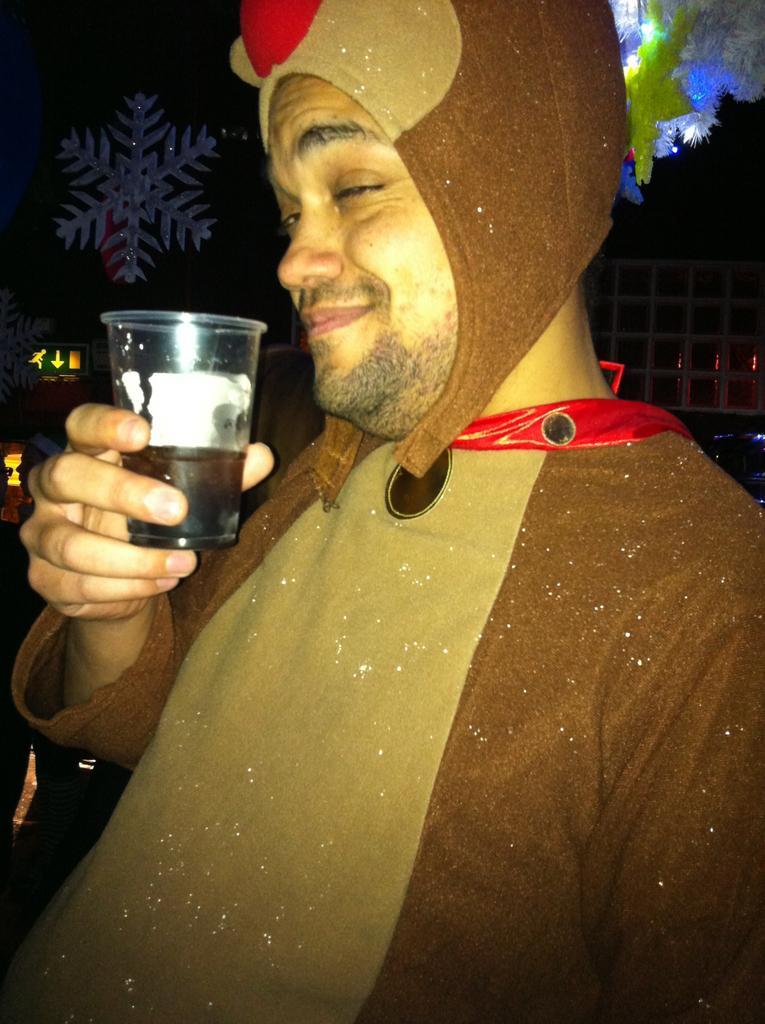How would you summarize this image in a sentence or two? In this image I see a man who is wearing a costume and is holding a glass. 